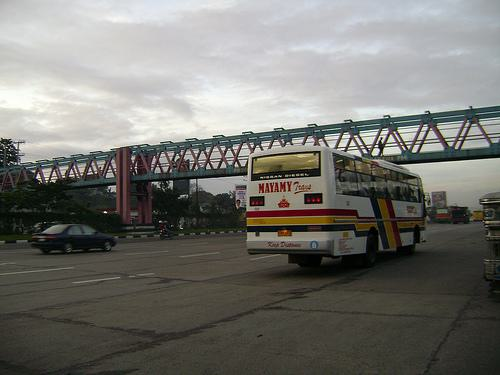How many buss are there in the image? 1 